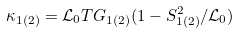Convert formula to latex. <formula><loc_0><loc_0><loc_500><loc_500>\kappa _ { 1 ( 2 ) } = \mathcal { L } _ { 0 } T G _ { 1 ( 2 ) } ( 1 - S _ { 1 ( 2 ) } ^ { 2 } / \mathcal { L } _ { 0 } )</formula> 